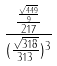<formula> <loc_0><loc_0><loc_500><loc_500>\frac { \frac { \frac { \sqrt { 4 4 9 } } { 9 } } { 2 1 7 } } { ( \frac { \sqrt { 3 1 8 } } { 3 1 3 } ) ^ { 3 } }</formula> 